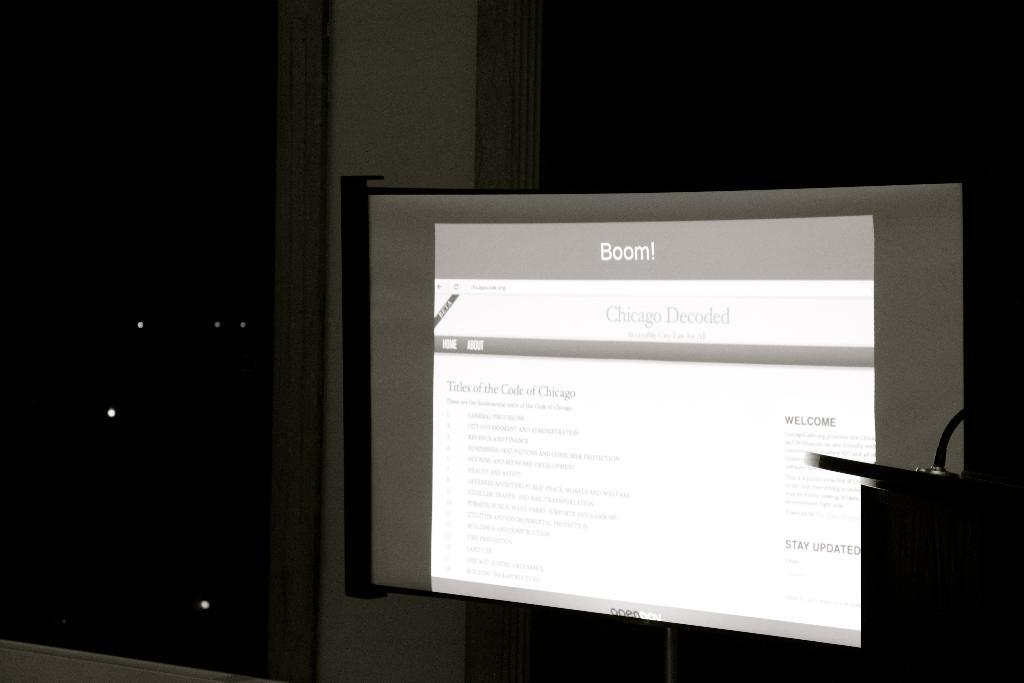What is the main object in the image? There is a screen on a board in the image. What invention from history is depicted in the image? There is no specific invention from history depicted in the image; it only shows a screen on a board. How many people are sleeping in the image? There are no people present in the image, let alone sleeping. 